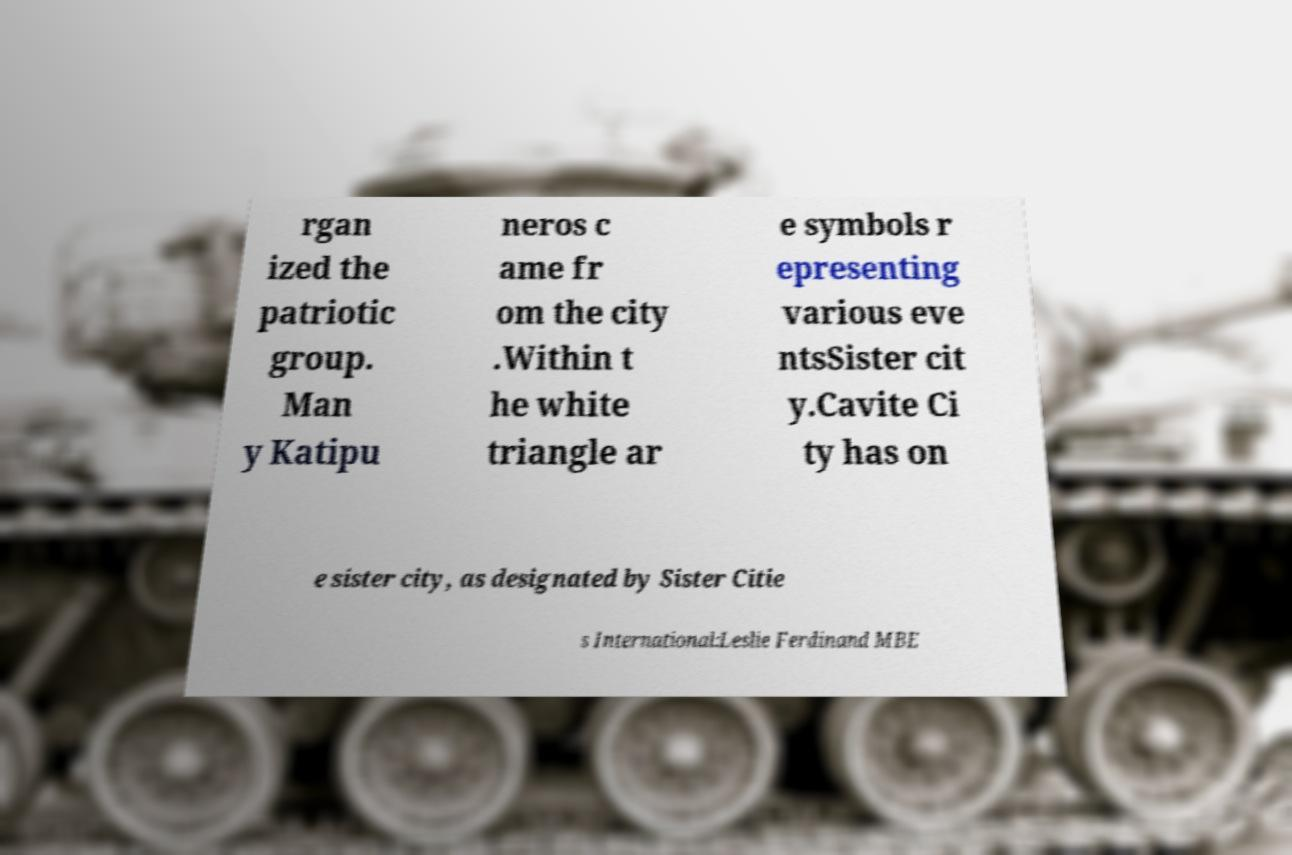Can you read and provide the text displayed in the image?This photo seems to have some interesting text. Can you extract and type it out for me? rgan ized the patriotic group. Man y Katipu neros c ame fr om the city .Within t he white triangle ar e symbols r epresenting various eve ntsSister cit y.Cavite Ci ty has on e sister city, as designated by Sister Citie s International:Leslie Ferdinand MBE 